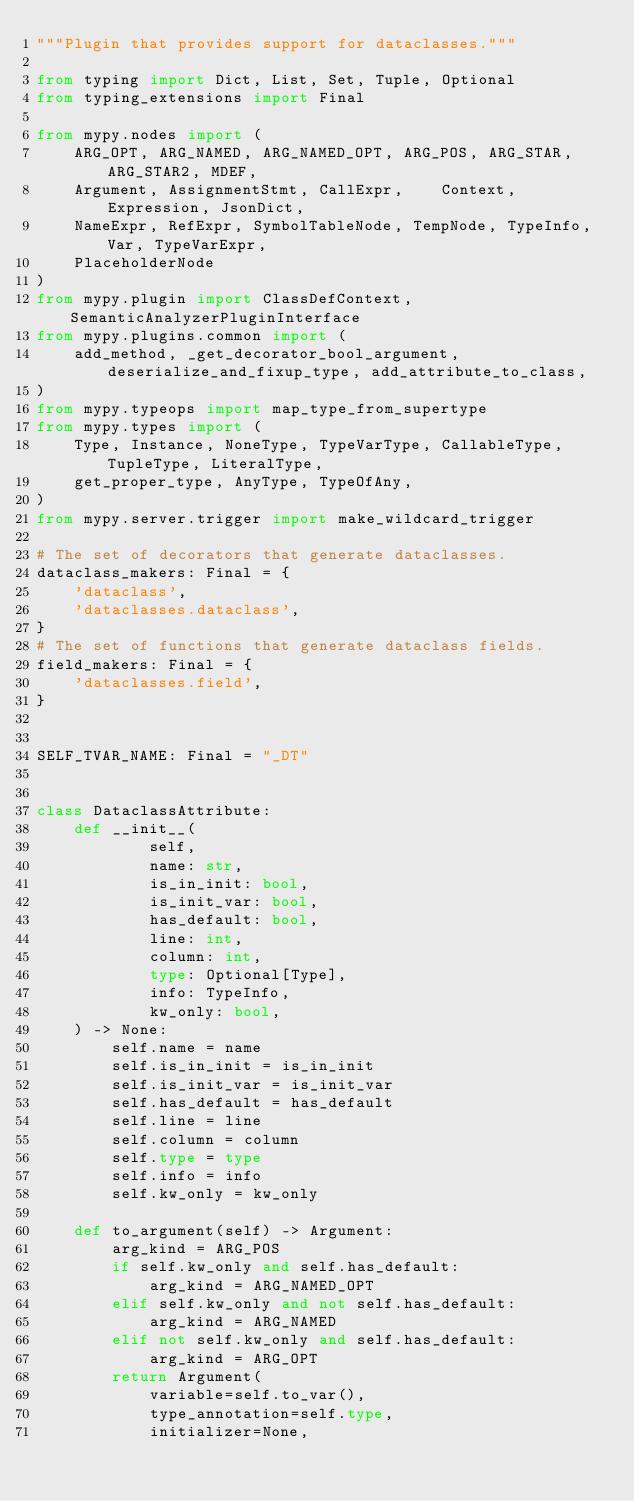Convert code to text. <code><loc_0><loc_0><loc_500><loc_500><_Python_>"""Plugin that provides support for dataclasses."""

from typing import Dict, List, Set, Tuple, Optional
from typing_extensions import Final

from mypy.nodes import (
    ARG_OPT, ARG_NAMED, ARG_NAMED_OPT, ARG_POS, ARG_STAR, ARG_STAR2, MDEF,
    Argument, AssignmentStmt, CallExpr,    Context, Expression, JsonDict,
    NameExpr, RefExpr, SymbolTableNode, TempNode, TypeInfo, Var, TypeVarExpr,
    PlaceholderNode
)
from mypy.plugin import ClassDefContext, SemanticAnalyzerPluginInterface
from mypy.plugins.common import (
    add_method, _get_decorator_bool_argument, deserialize_and_fixup_type, add_attribute_to_class,
)
from mypy.typeops import map_type_from_supertype
from mypy.types import (
    Type, Instance, NoneType, TypeVarType, CallableType, TupleType, LiteralType,
    get_proper_type, AnyType, TypeOfAny,
)
from mypy.server.trigger import make_wildcard_trigger

# The set of decorators that generate dataclasses.
dataclass_makers: Final = {
    'dataclass',
    'dataclasses.dataclass',
}
# The set of functions that generate dataclass fields.
field_makers: Final = {
    'dataclasses.field',
}


SELF_TVAR_NAME: Final = "_DT"


class DataclassAttribute:
    def __init__(
            self,
            name: str,
            is_in_init: bool,
            is_init_var: bool,
            has_default: bool,
            line: int,
            column: int,
            type: Optional[Type],
            info: TypeInfo,
            kw_only: bool,
    ) -> None:
        self.name = name
        self.is_in_init = is_in_init
        self.is_init_var = is_init_var
        self.has_default = has_default
        self.line = line
        self.column = column
        self.type = type
        self.info = info
        self.kw_only = kw_only

    def to_argument(self) -> Argument:
        arg_kind = ARG_POS
        if self.kw_only and self.has_default:
            arg_kind = ARG_NAMED_OPT
        elif self.kw_only and not self.has_default:
            arg_kind = ARG_NAMED
        elif not self.kw_only and self.has_default:
            arg_kind = ARG_OPT
        return Argument(
            variable=self.to_var(),
            type_annotation=self.type,
            initializer=None,</code> 